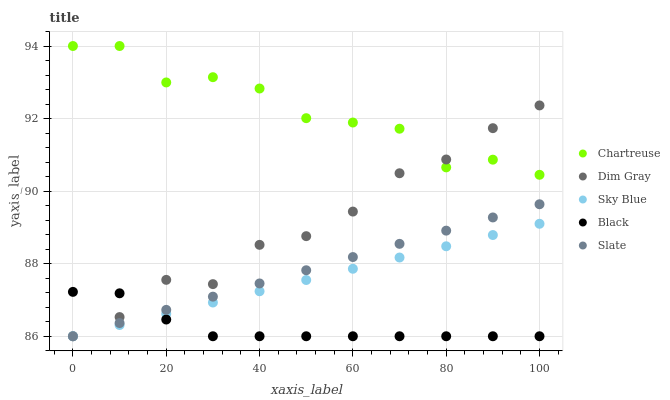Does Black have the minimum area under the curve?
Answer yes or no. Yes. Does Chartreuse have the maximum area under the curve?
Answer yes or no. Yes. Does Dim Gray have the minimum area under the curve?
Answer yes or no. No. Does Dim Gray have the maximum area under the curve?
Answer yes or no. No. Is Sky Blue the smoothest?
Answer yes or no. Yes. Is Chartreuse the roughest?
Answer yes or no. Yes. Is Dim Gray the smoothest?
Answer yes or no. No. Is Dim Gray the roughest?
Answer yes or no. No. Does Sky Blue have the lowest value?
Answer yes or no. Yes. Does Chartreuse have the lowest value?
Answer yes or no. No. Does Chartreuse have the highest value?
Answer yes or no. Yes. Does Dim Gray have the highest value?
Answer yes or no. No. Is Black less than Chartreuse?
Answer yes or no. Yes. Is Chartreuse greater than Sky Blue?
Answer yes or no. Yes. Does Sky Blue intersect Slate?
Answer yes or no. Yes. Is Sky Blue less than Slate?
Answer yes or no. No. Is Sky Blue greater than Slate?
Answer yes or no. No. Does Black intersect Chartreuse?
Answer yes or no. No. 